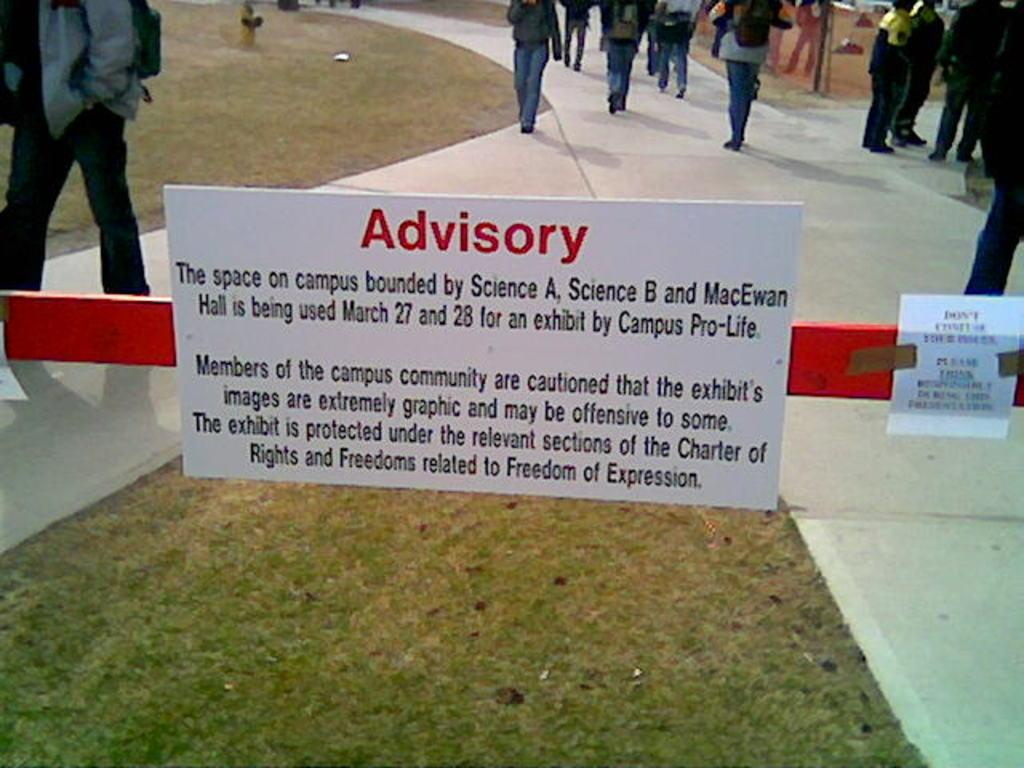What type of sign is visible in the image? There is a caution board in the image. What can be seen in the background of the image? There is a footpath in the image, with grass on either side. What are the people in the image doing? There are people walking on the footpath. What type of hill can be seen in the background of the image? There is no hill present in the image; it features a footpath with grass on either side. What type of coal is being mined in the image? There is no coal mining activity depicted in the image; it shows a caution board, a footpath, and people walking on it. 